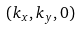<formula> <loc_0><loc_0><loc_500><loc_500>( k _ { x } , k _ { y } , 0 )</formula> 